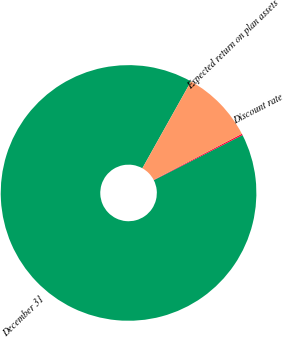Convert chart to OTSL. <chart><loc_0><loc_0><loc_500><loc_500><pie_chart><fcel>December 31<fcel>Discount rate<fcel>Expected return on plan assets<nl><fcel>90.59%<fcel>0.18%<fcel>9.22%<nl></chart> 